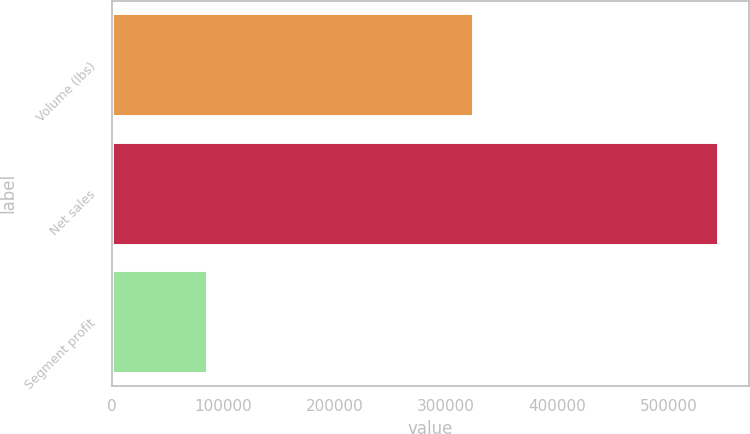Convert chart to OTSL. <chart><loc_0><loc_0><loc_500><loc_500><bar_chart><fcel>Volume (lbs)<fcel>Net sales<fcel>Segment profit<nl><fcel>324895<fcel>545014<fcel>85304<nl></chart> 